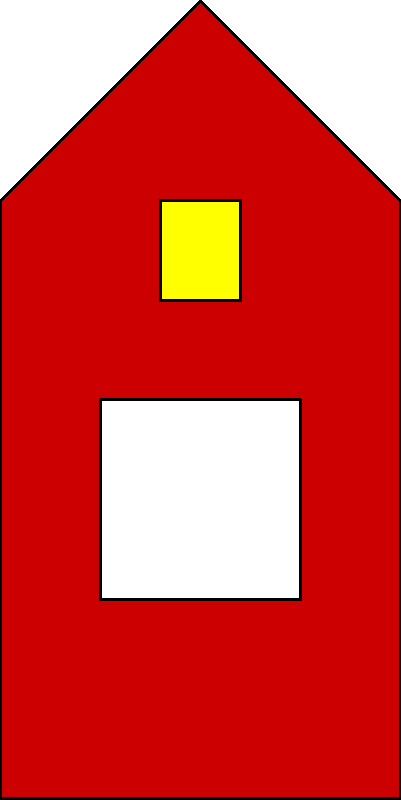Which European royal dynasty is most closely associated with the coat of arms depicted in the image, featuring a red shield with a white cross and a golden lion? To identify the royal dynasty associated with this coat of arms, let's analyze its components step-by-step:

1. Shield color: The shield is red (gules in heraldic terms), which is a common color in many European coats of arms.

2. White cross: The prominent white (argent) cross on the shield is a key feature. This type of cross, known as a Greek cross, is associated with various European monarchies and nations.

3. Golden lion: The presence of a golden (or) lion in the upper part of the shield is a crucial identifying element.

4. Overall composition: The combination of a red shield, white cross, and golden lion is distinctive.

These elements together point to the House of Denmark, also known as the Oldenburg dynasty. The coat of arms depicted is a simplified version of the Danish royal coat of arms, which has been used since the Middle Ages.

The red shield with a white cross is the Dannebrog, the national flag and symbol of Denmark. The golden lions (typically three) have been a symbol of Danish royalty since the 12th century.

While other European royal houses have used similar elements, this specific combination is most closely associated with the Danish royal family and the House of Oldenburg, which has ruled Denmark since 1448.
Answer: House of Oldenburg (Danish royal dynasty) 